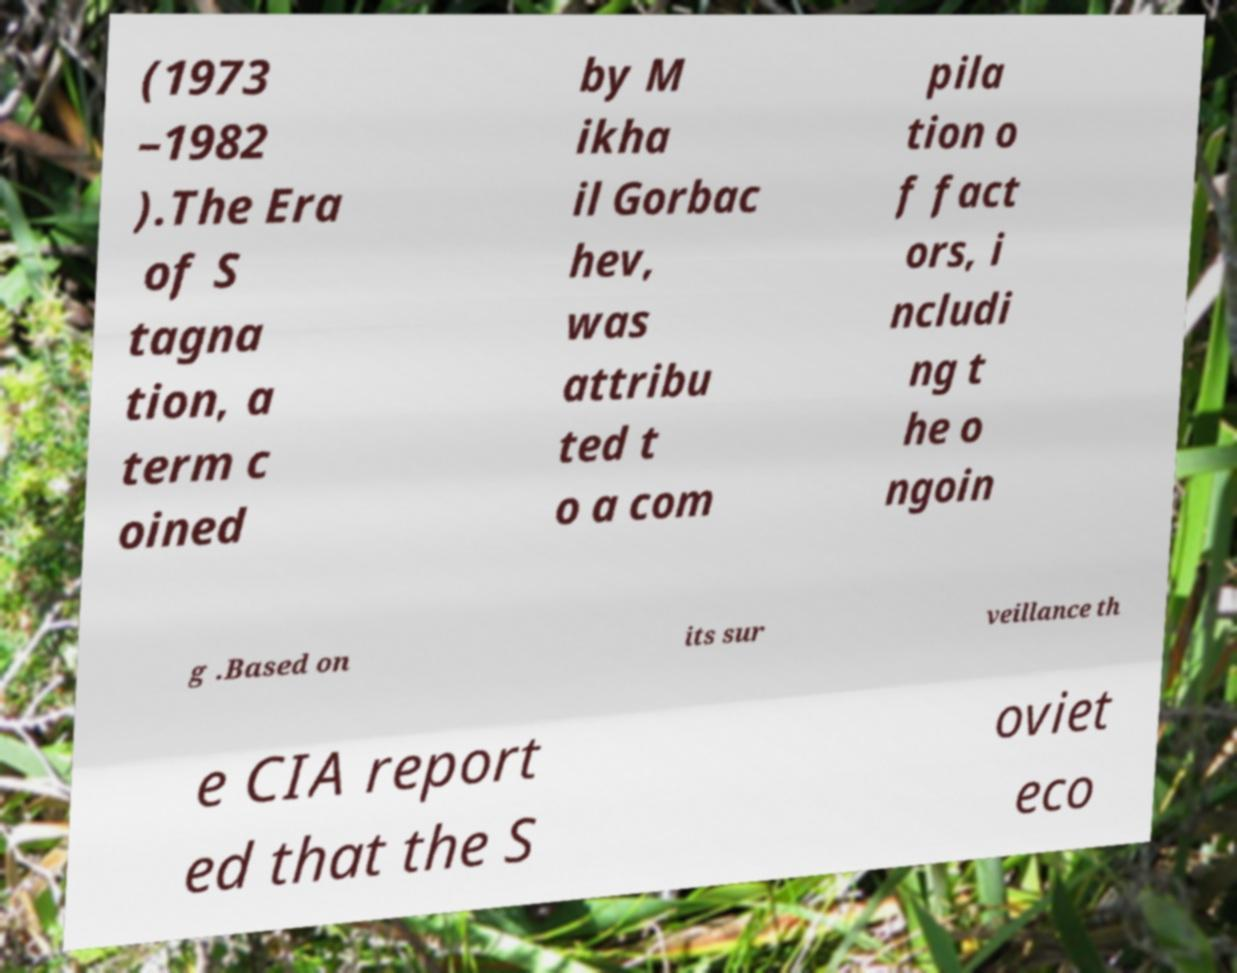What messages or text are displayed in this image? I need them in a readable, typed format. (1973 –1982 ).The Era of S tagna tion, a term c oined by M ikha il Gorbac hev, was attribu ted t o a com pila tion o f fact ors, i ncludi ng t he o ngoin g .Based on its sur veillance th e CIA report ed that the S oviet eco 